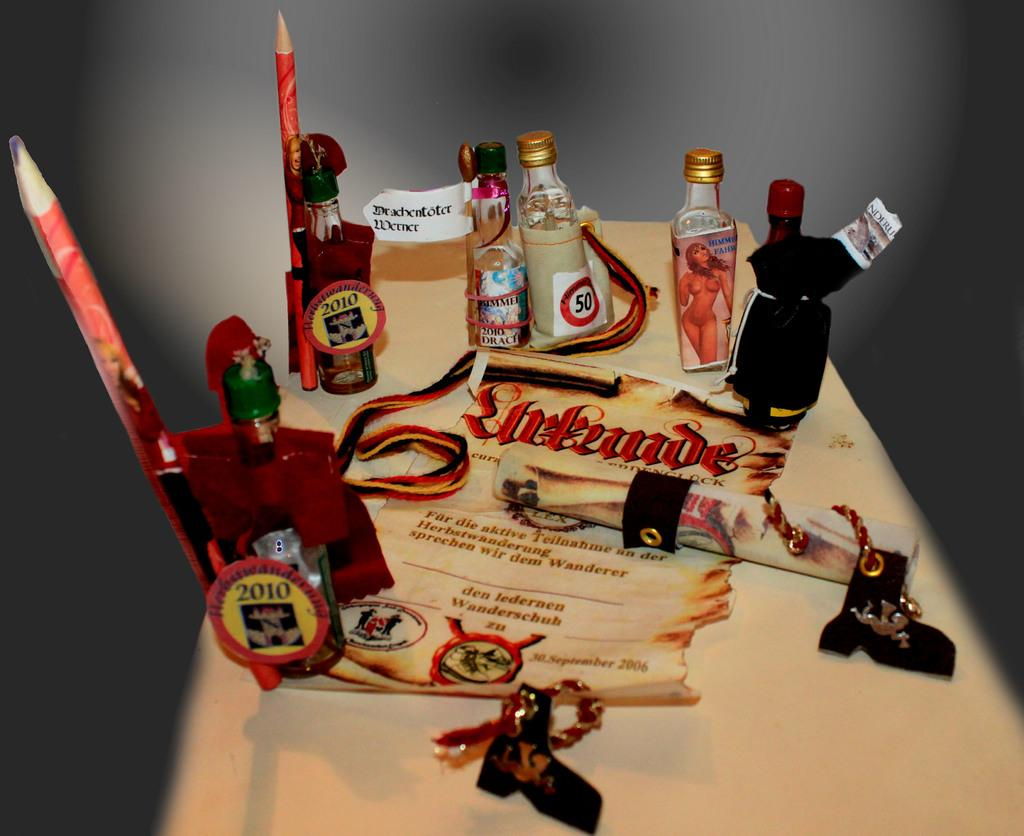What objects are on the table in the image? There are several glass bottles, pencils, and charts on the table. What type of writing instrument can be seen on the table? Pencils are on the table. What type of informational material is on the table? Charts are on the table. Can you see a bee buzzing around the glass bottles in the image? No, there is no bee present in the image. What type of grain is visible on the table in the image? There is no grain visible on the table in the image. 